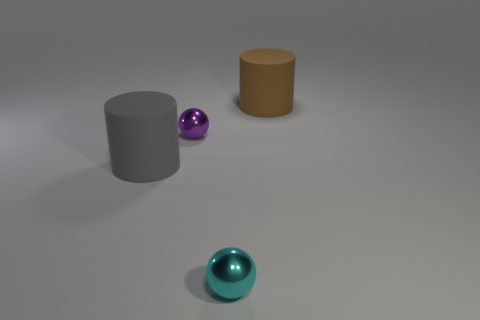Add 3 tiny blue rubber spheres. How many objects exist? 7 Subtract 1 balls. How many balls are left? 1 Subtract all purple spheres. How many spheres are left? 1 Subtract all green balls. Subtract all gray cylinders. How many balls are left? 2 Subtract all brown cubes. How many brown cylinders are left? 1 Subtract all small metallic things. Subtract all small purple spheres. How many objects are left? 1 Add 1 purple balls. How many purple balls are left? 2 Add 1 big gray rubber cylinders. How many big gray rubber cylinders exist? 2 Subtract 0 red spheres. How many objects are left? 4 